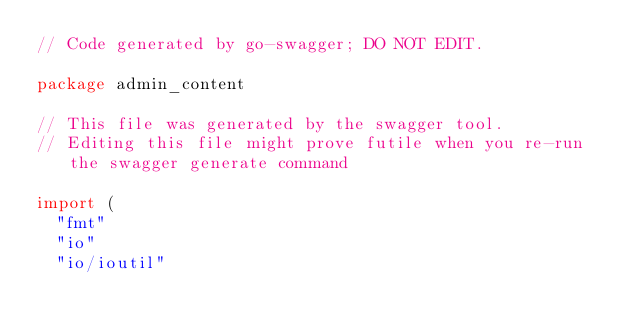<code> <loc_0><loc_0><loc_500><loc_500><_Go_>// Code generated by go-swagger; DO NOT EDIT.

package admin_content

// This file was generated by the swagger tool.
// Editing this file might prove futile when you re-run the swagger generate command

import (
	"fmt"
	"io"
	"io/ioutil"
</code> 